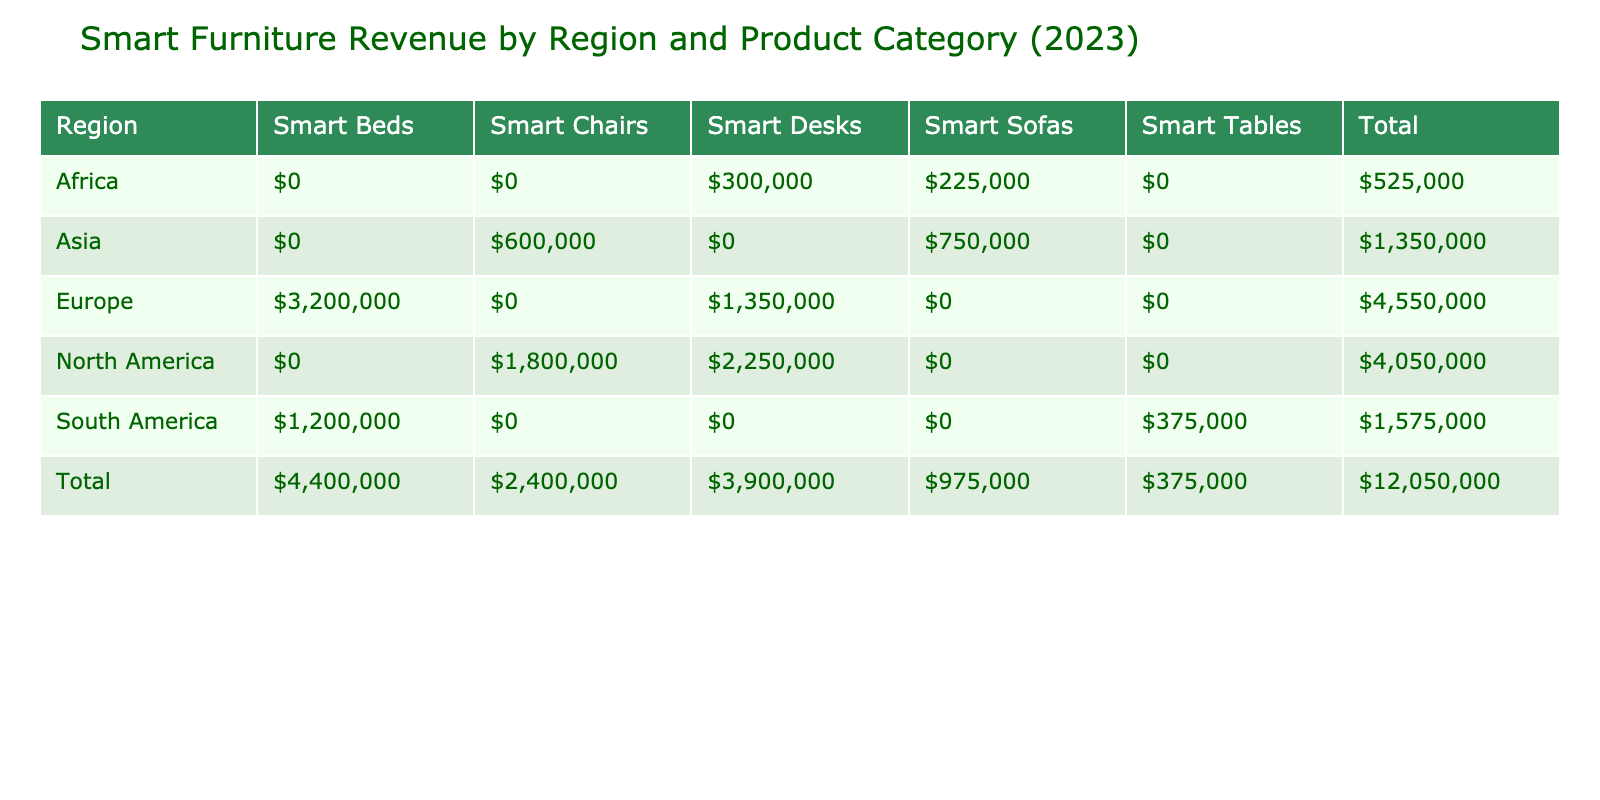What is the total revenue generated from smart furniture in North America? To find the total revenue for North America, I look at the revenue figures for each product category sold in that region. The values are: FlexiDesk 2000 ($2,250,000) and ErgoSeat Pro ($1,800,000). Adding these together gives $2,250,000 + $1,800,000 = $4,050,000.
Answer: $4,050,000 Which product category had the highest revenue in Europe? The revenues for each product category in Europe are SnoozeSmart Bed ($3,200,000) and AdaptDesk Elite ($1,350,000). Comparing these two values, $3,200,000 is greater than $1,350,000, so the product category with the highest revenue is Smart Beds.
Answer: Smart Beds Did South America generate more revenue from Smart Tables than Smart Beds? In South America, the revenue from Smart Tables is $375,000 and from Smart Beds is $1,200,000. Since $375,000 is less than $1,200,000, the statement is false.
Answer: No What is the average revenue per product category sold in Asia? In Asia, there are two product categories: Smart Sofas and Smart Chairs. Their revenues are $750,000 (ComfyTech Sofa) and $600,000 (ComfortWave Chair). Adding these gives $750,000 + $600,000 = $1,350,000. There are 2 categories, so the average revenue is $1,350,000 / 2 = $675,000.
Answer: $675,000 What is the total revenue for all regions combined? To calculate the total revenue for all regions, I need to sum the revenues from each region. The total from the regions is: $2,250,000 (North America Smart Desks) + $1,800,000 (North America Smart Chairs) + $3,200,000 (Europe Smart Beds) + $1,350,000 (Europe Smart Desks) + $750,000 (Asia Smart Sofas) + $600,000 (Asia Smart Chairs) + $375,000 (South America Smart Tables) + $1,200,000 (South America Smart Beds) + $300,000 (Africa Smart Desks) + $225,000 (Africa Smart Sofas). Summing these values results in $12,000,000.
Answer: $12,000,000 Which region sold the least number of units, and what was the total units sold in that region? By examining the units sold in each region, I find that South America sold the fewest units with a total of 550 units (250 from Smart Tables and 300 from Smart Beds combined).
Answer: South America, 550 units 